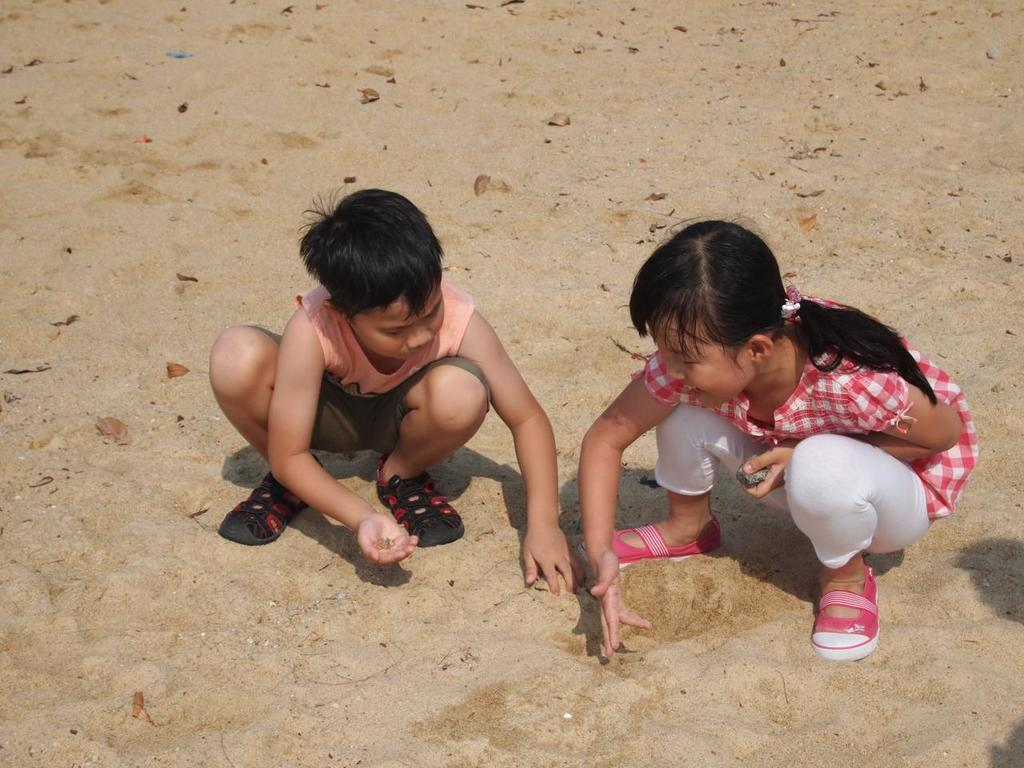Who are the two people in the image? There is a boy and a girl in the image. What are they sitting on? They are both sitting on the sand. What is the boy holding? The boy is holding some sand. What is the girl holding? The girl is holding a stone. What else can be seen near them? There are dried leaves beside them. What type of crook is the monkey using to steal the pump in the image? There is no monkey, crook, or pump present in the image. 